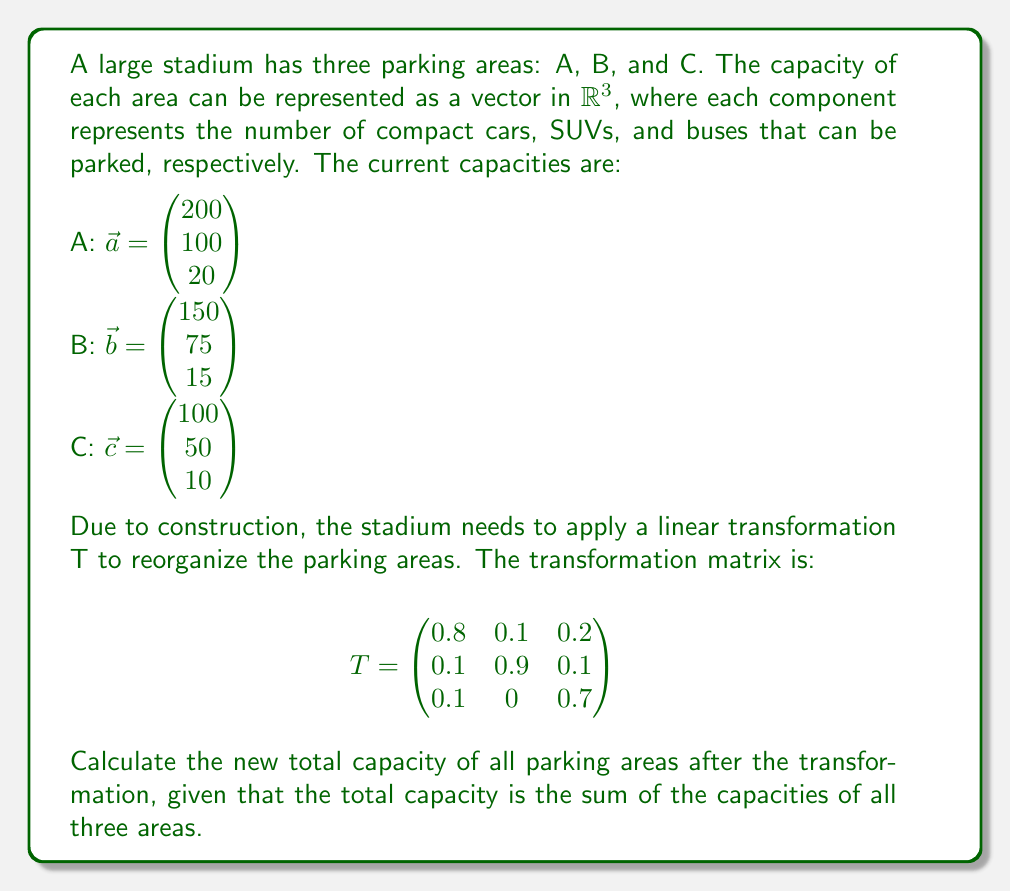Teach me how to tackle this problem. To solve this problem, we need to follow these steps:

1. Apply the linear transformation T to each parking area vector.
2. Sum up the transformed vectors to get the new total capacity.

Step 1: Applying the transformation

For each parking area vector $\vec{v}$, we calculate $T\vec{v}$:

For area A:
$$T\vec{a} = \begin{pmatrix}
0.8 & 0.1 & 0.2 \\
0.1 & 0.9 & 0.1 \\
0.1 & 0 & 0.7
\end{pmatrix} \begin{pmatrix} 200 \\ 100 \\ 20 \end{pmatrix} = \begin{pmatrix}
0.8(200) + 0.1(100) + 0.2(20) \\
0.1(200) + 0.9(100) + 0.1(20) \\
0.1(200) + 0(100) + 0.7(20)
\end{pmatrix} = \begin{pmatrix} 174 \\ 112 \\ 34 \end{pmatrix}$$

For area B:
$$T\vec{b} = \begin{pmatrix}
0.8 & 0.1 & 0.2 \\
0.1 & 0.9 & 0.1 \\
0.1 & 0 & 0.7
\end{pmatrix} \begin{pmatrix} 150 \\ 75 \\ 15 \end{pmatrix} = \begin{pmatrix}
0.8(150) + 0.1(75) + 0.2(15) \\
0.1(150) + 0.9(75) + 0.1(15) \\
0.1(150) + 0(75) + 0.7(15)
\end{pmatrix} = \begin{pmatrix} 130.5 \\ 84 \\ 25.5 \end{pmatrix}$$

For area C:
$$T\vec{c} = \begin{pmatrix}
0.8 & 0.1 & 0.2 \\
0.1 & 0.9 & 0.1 \\
0.1 & 0 & 0.7
\end{pmatrix} \begin{pmatrix} 100 \\ 50 \\ 10 \end{pmatrix} = \begin{pmatrix}
0.8(100) + 0.1(50) + 0.2(10) \\
0.1(100) + 0.9(50) + 0.1(10) \\
0.1(100) + 0(50) + 0.7(10)
\end{pmatrix} = \begin{pmatrix} 87 \\ 56 \\ 17 \end{pmatrix}$$

Step 2: Summing up the transformed vectors

The new total capacity is the sum of the transformed vectors:

$$\begin{pmatrix} 174 \\ 112 \\ 34 \end{pmatrix} + \begin{pmatrix} 130.5 \\ 84 \\ 25.5 \end{pmatrix} + \begin{pmatrix} 87 \\ 56 \\ 17 \end{pmatrix} = \begin{pmatrix} 391.5 \\ 252 \\ 76.5 \end{pmatrix}$$

This result represents the new total capacity of all parking areas after the transformation, where the components represent compact cars, SUVs, and buses, respectively.
Answer: The new total capacity of all parking areas after the transformation is $\begin{pmatrix} 391.5 \\ 252 \\ 76.5 \end{pmatrix}$, which means 391.5 compact cars, 252 SUVs, and 76.5 buses. 